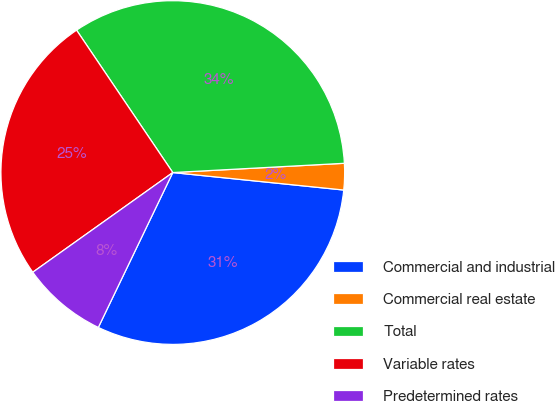Convert chart to OTSL. <chart><loc_0><loc_0><loc_500><loc_500><pie_chart><fcel>Commercial and industrial<fcel>Commercial real estate<fcel>Total<fcel>Variable rates<fcel>Predetermined rates<nl><fcel>30.51%<fcel>2.48%<fcel>33.6%<fcel>25.39%<fcel>8.02%<nl></chart> 